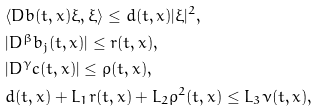<formula> <loc_0><loc_0><loc_500><loc_500>& \langle D b ( t , x ) \xi , \xi \rangle \leq d ( t , x ) | \xi | ^ { 2 } , \\ & | D ^ { \beta } b _ { j } ( t , x ) | \leq r ( t , x ) , \\ & | D ^ { \gamma } c ( t , x ) | \leq \varrho ( t , x ) , \\ & d ( t , x ) + L _ { 1 } r ( t , x ) + L _ { 2 } \varrho ^ { 2 } ( t , x ) \leq L _ { 3 } \nu ( t , x ) ,</formula> 